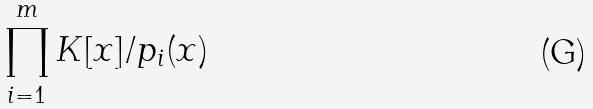Convert formula to latex. <formula><loc_0><loc_0><loc_500><loc_500>\prod _ { i = 1 } ^ { m } K [ x ] / p _ { i } ( x )</formula> 